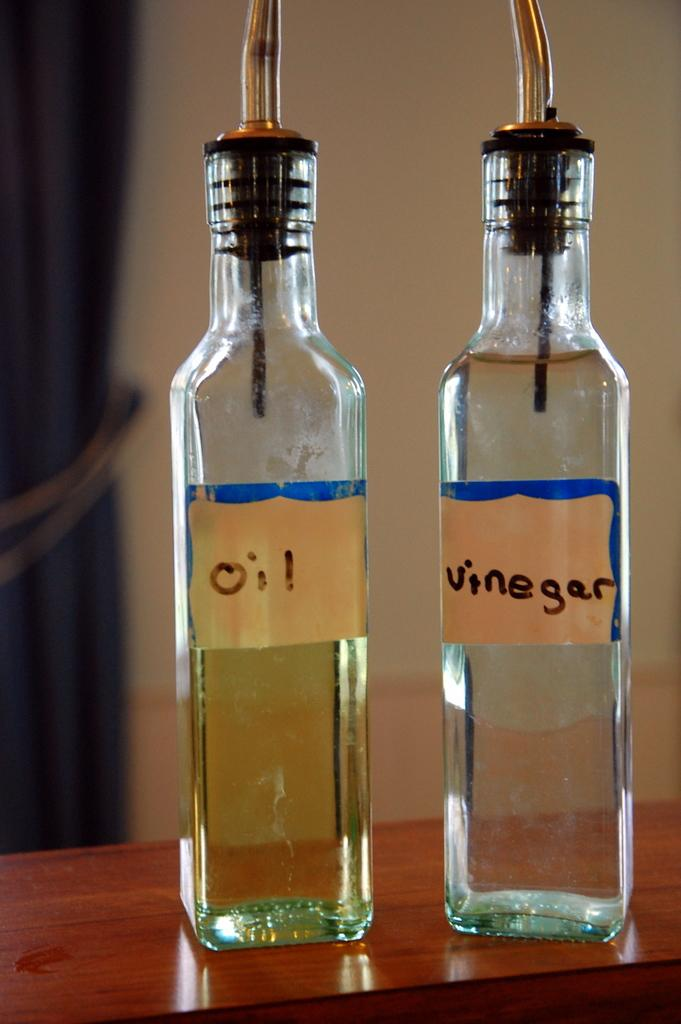<image>
Create a compact narrative representing the image presented. Bottle of oil next to a bottle of vinegar. 